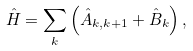<formula> <loc_0><loc_0><loc_500><loc_500>\hat { H } = \sum _ { k } \left ( \hat { A } _ { k , k + 1 } + \hat { B } _ { k } \right ) ,</formula> 